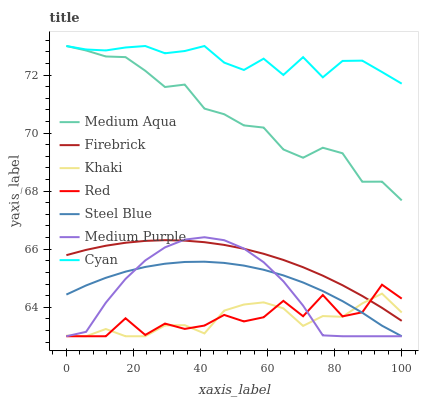Does Khaki have the minimum area under the curve?
Answer yes or no. Yes. Does Firebrick have the minimum area under the curve?
Answer yes or no. No. Does Firebrick have the maximum area under the curve?
Answer yes or no. No. Is Steel Blue the smoothest?
Answer yes or no. No. Is Steel Blue the roughest?
Answer yes or no. No. Does Firebrick have the lowest value?
Answer yes or no. No. Does Firebrick have the highest value?
Answer yes or no. No. Is Red less than Medium Aqua?
Answer yes or no. Yes. Is Medium Aqua greater than Red?
Answer yes or no. Yes. Does Red intersect Medium Aqua?
Answer yes or no. No. 